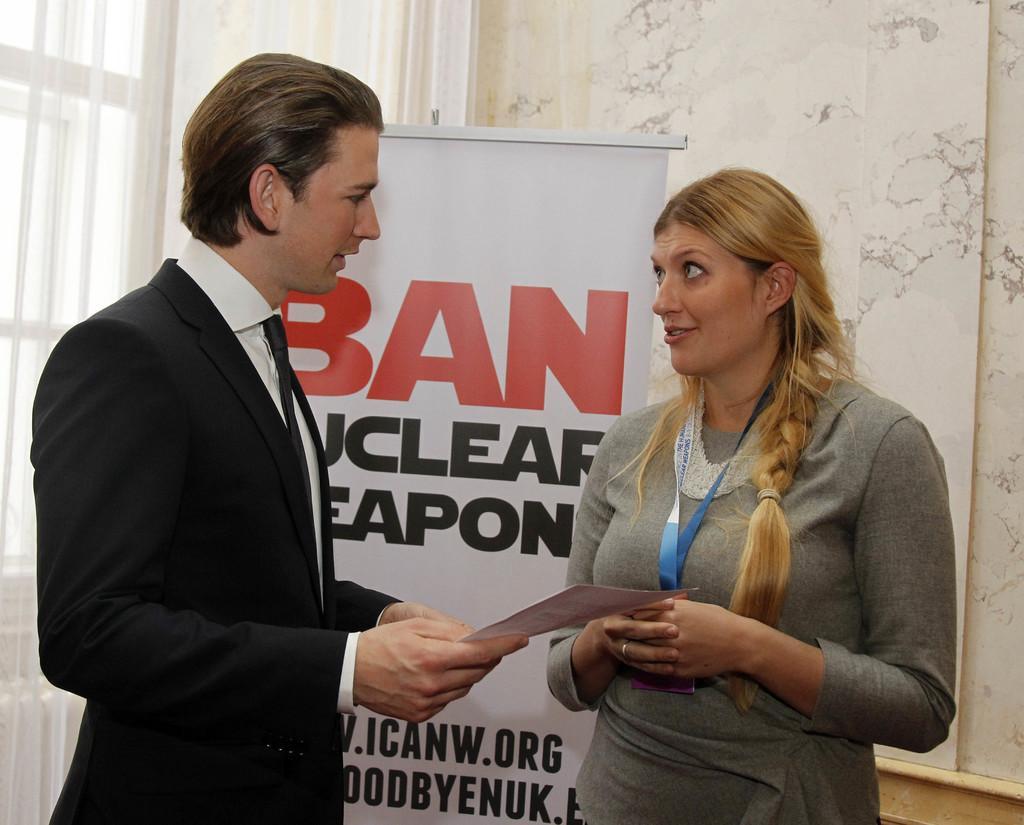In one or two sentences, can you explain what this image depicts? In this image I can see two persons holding paper. Back I can see a white board,curtain,window and white wall. 